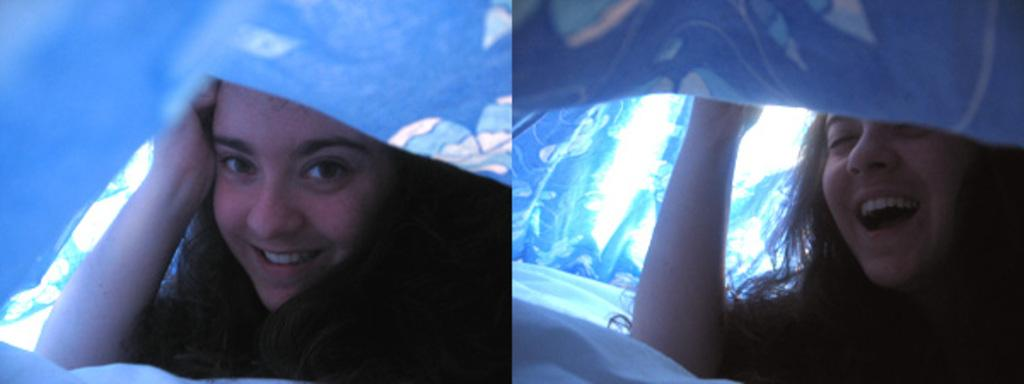Who is present in the image? There is a woman in the image. What is the woman doing in the image? The woman is under a blanket. What is the woman's facial expression in the image? The woman is smiling. What books is the woman holding in the image? There are no books visible in the image; the woman is under a blanket and smiling. Can you see a picture of a goose in the image? There is no picture of a goose present in the image. 